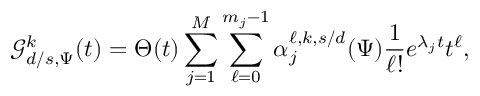Convert formula to latex. <formula><loc_0><loc_0><loc_500><loc_500>\mathcal { G } _ { d / s , \Psi } ^ { k } ( t ) = \Theta ( t ) \sum _ { j = 1 } ^ { M } \sum _ { \ell = 0 } ^ { m _ { j } - 1 } \alpha _ { j } ^ { \ell , k , s / d } ( \Psi ) \frac { 1 } { \ell ! } e ^ { \lambda _ { j } t } t ^ { \ell } ,</formula> 